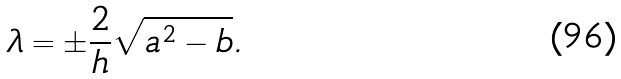<formula> <loc_0><loc_0><loc_500><loc_500>\lambda = \pm \frac { 2 } { h } \sqrt { a ^ { 2 } - b } .</formula> 